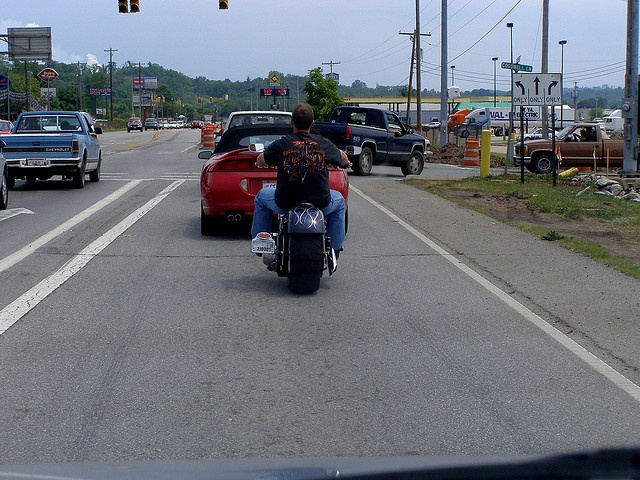Describe the objects in this image and their specific colors. I can see truck in lightblue, black, gray, navy, and blue tones, car in lightblue, black, maroon, gray, and brown tones, people in lightblue, black, navy, maroon, and gray tones, truck in lightblue, black, gray, navy, and blue tones, and motorcycle in lightblue, black, gray, navy, and darkgray tones in this image. 